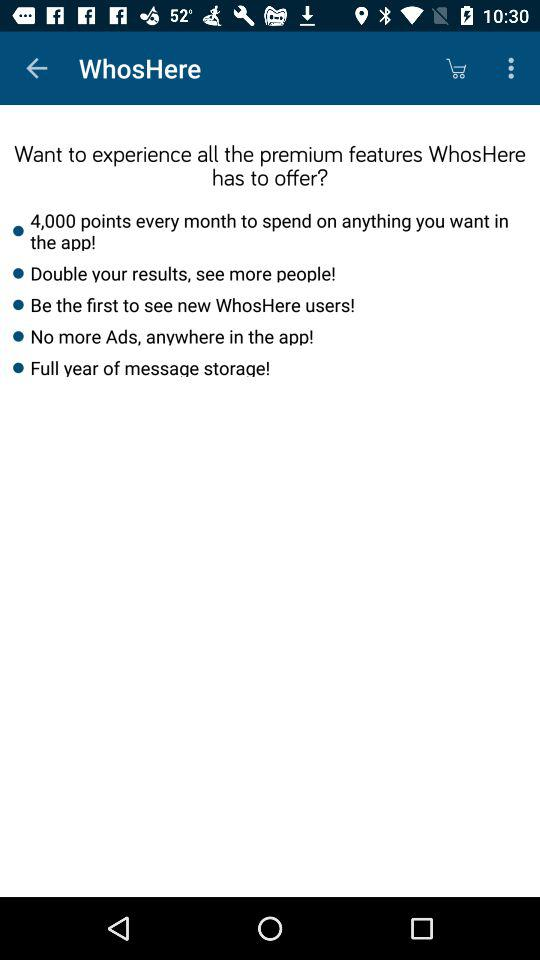What benefits might a user experience from these premium features? These premium features are designed to significantly enhance the user experience. For instance, getting 4,000 points per month allows for greater freedom within the app. Doubling the results can improve the chances of finding interesting people. Early access to new users provides a networking advantage, and removing ads ensures a smoother, more enjoyable usage. Lastly, extended message storage is practical for maintaining long-term conversations without the worry of losing any important messages. 